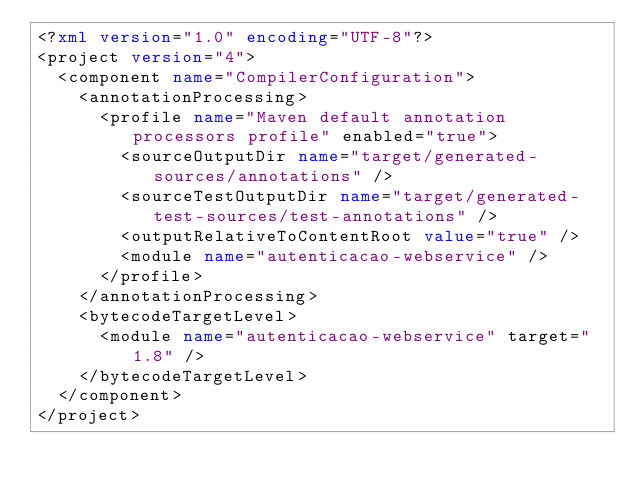<code> <loc_0><loc_0><loc_500><loc_500><_XML_><?xml version="1.0" encoding="UTF-8"?>
<project version="4">
  <component name="CompilerConfiguration">
    <annotationProcessing>
      <profile name="Maven default annotation processors profile" enabled="true">
        <sourceOutputDir name="target/generated-sources/annotations" />
        <sourceTestOutputDir name="target/generated-test-sources/test-annotations" />
        <outputRelativeToContentRoot value="true" />
        <module name="autenticacao-webservice" />
      </profile>
    </annotationProcessing>
    <bytecodeTargetLevel>
      <module name="autenticacao-webservice" target="1.8" />
    </bytecodeTargetLevel>
  </component>
</project></code> 